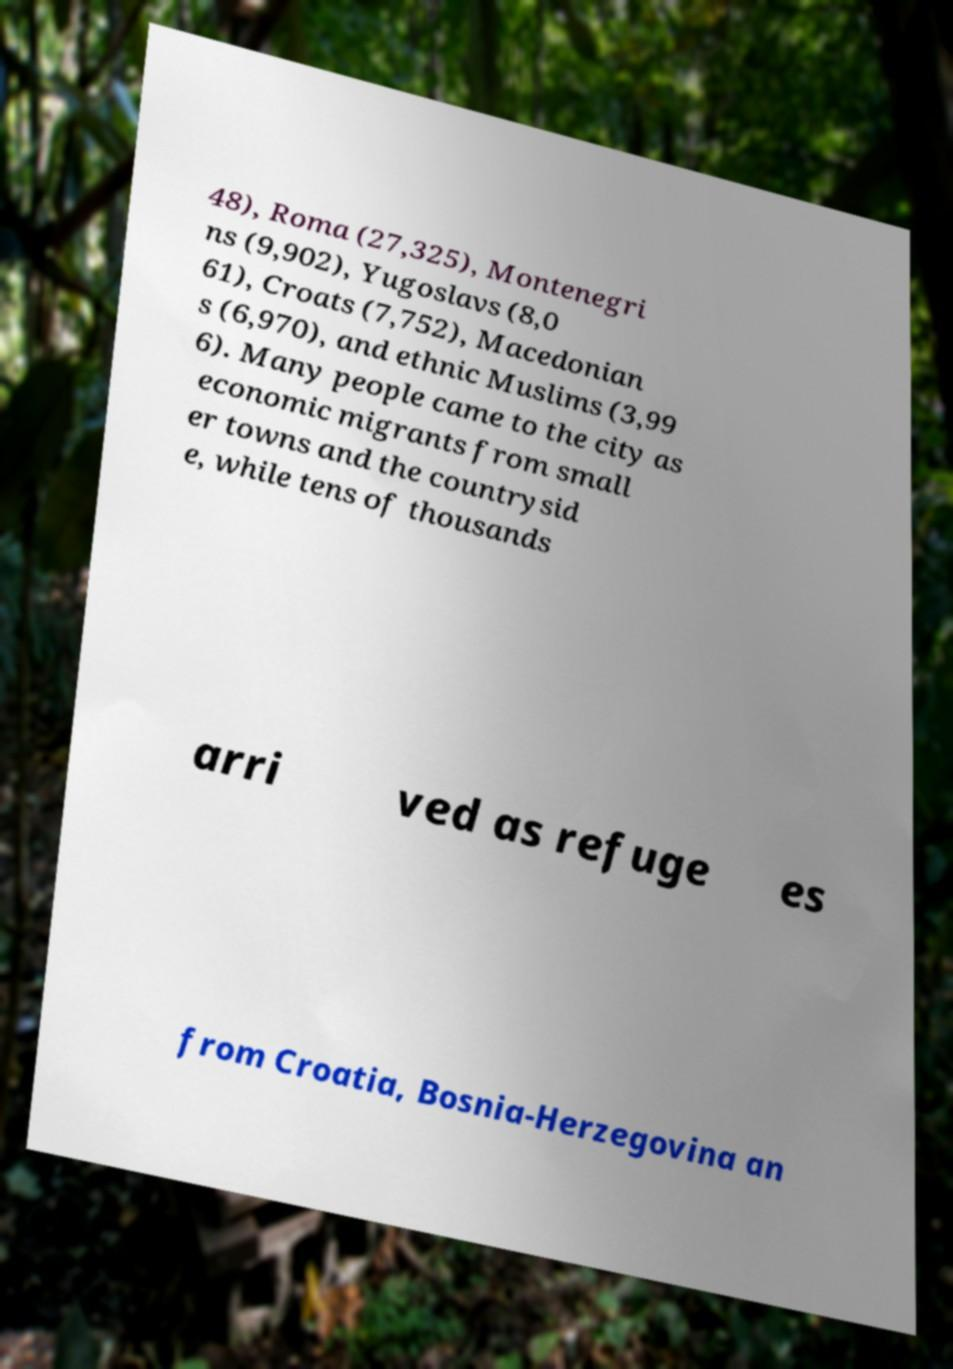Please identify and transcribe the text found in this image. 48), Roma (27,325), Montenegri ns (9,902), Yugoslavs (8,0 61), Croats (7,752), Macedonian s (6,970), and ethnic Muslims (3,99 6). Many people came to the city as economic migrants from small er towns and the countrysid e, while tens of thousands arri ved as refuge es from Croatia, Bosnia-Herzegovina an 